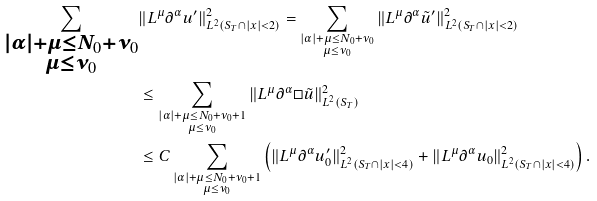Convert formula to latex. <formula><loc_0><loc_0><loc_500><loc_500>\sum _ { \substack { | \alpha | + \mu \leq N _ { 0 } + \nu _ { 0 } \\ \mu \leq \nu _ { 0 } } } & \| L ^ { \mu } \partial ^ { \alpha } u ^ { \prime } \| ^ { 2 } _ { L ^ { 2 } ( S _ { T } \cap | x | < 2 ) } = \sum _ { \substack { | \alpha | + \mu \leq N _ { 0 } + \nu _ { 0 } \\ \mu \leq \nu _ { 0 } } } \| L ^ { \mu } \partial ^ { \alpha } \tilde { u } ^ { \prime } \| ^ { 2 } _ { L ^ { 2 } ( S _ { T } \cap | x | < 2 ) } \\ & \leq \sum _ { \substack { | \alpha | + \mu \leq N _ { 0 } + \nu _ { 0 } + 1 \\ \mu \leq \nu _ { 0 } } } \| L ^ { \mu } \partial ^ { \alpha } \square \tilde { u } \| ^ { 2 } _ { L ^ { 2 } ( S _ { T } ) } \\ & \leq C \sum _ { \substack { | \alpha | + \mu \leq N _ { 0 } + \nu _ { 0 } + 1 \\ \mu \leq \nu _ { 0 } } } \left ( \| L ^ { \mu } \partial ^ { \alpha } u ^ { \prime } _ { 0 } \| ^ { 2 } _ { L ^ { 2 } ( S _ { T } \cap | x | < 4 ) } + \| L ^ { \mu } \partial ^ { \alpha } u _ { 0 } \| ^ { 2 } _ { L ^ { 2 } ( S _ { T } \cap | x | < 4 ) } \right ) .</formula> 